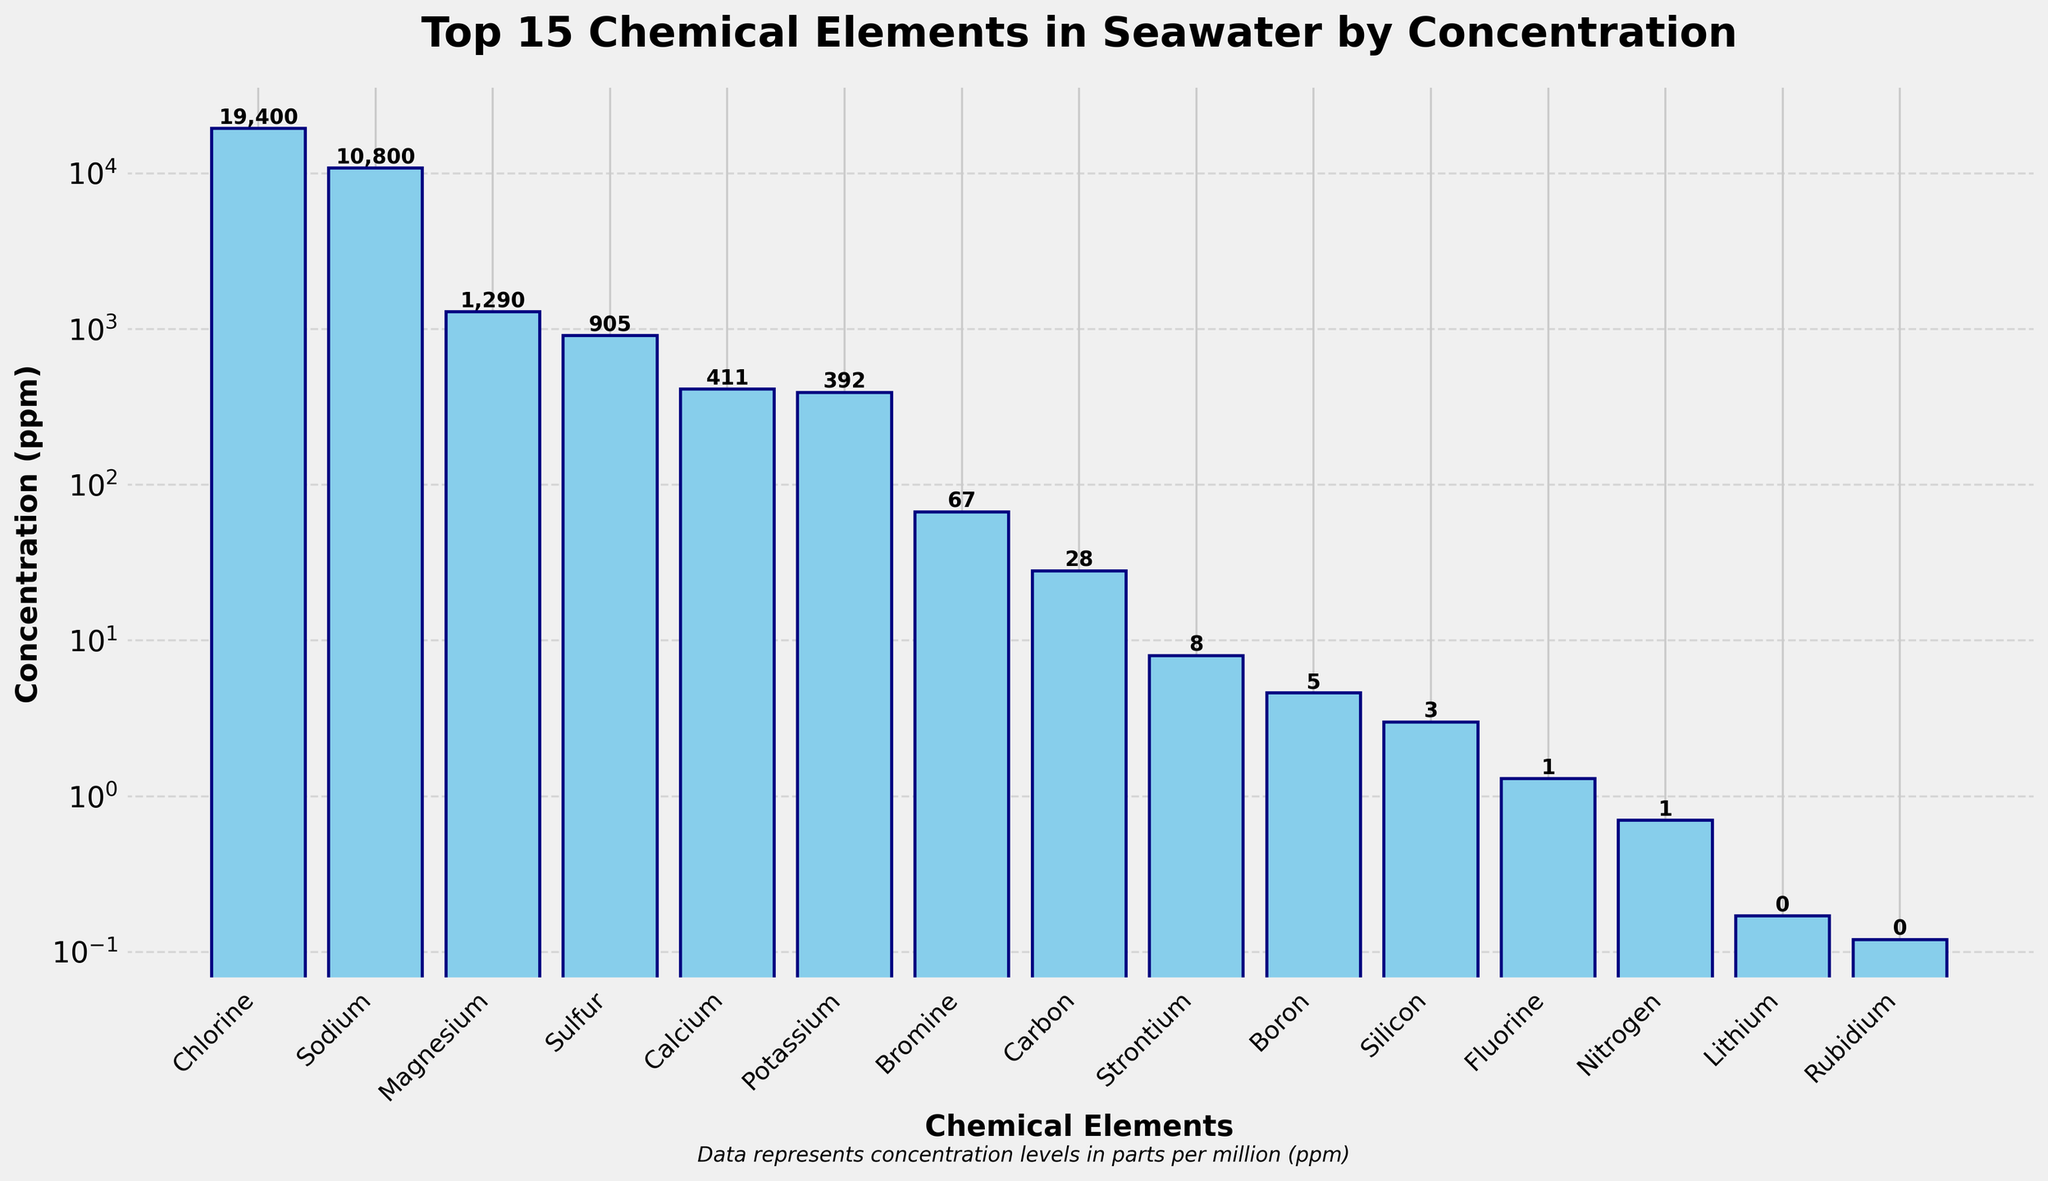Which element has the highest concentration in seawater? From the bar chart, observe the height of the bars. The tallest bar represents the element with the highest concentration.
Answer: Chlorine How does the concentration of sodium compare to that of chlorine? Compare the heights of the bars labeled 'Sodium' and 'Chlorine'. The bar for Chlorine is almost twice as high as the bar for Sodium, indicating Chlorine has a higher concentration.
Answer: Chlorine has a higher concentration than Sodium Is the concentration of magnesium higher than that of sulfur? Look at the bars for Magnesium and Sulfur. The bar for Magnesium is higher than the bar for Sulfur, indicating that the concentration of Magnesium is higher.
Answer: Yes What's the difference in concentration between calcium and potassium? Identify the bars for Calcium and Potassium and look at the numerical values on each. Calcium has a concentration of 411 ppm, and Potassium has 392 ppm. Subtract the smaller from the larger value.
Answer: 19 ppm Which elements have concentrations lower than 10 ppm? Examine the bars and their corresponding concentration values. Elements like Strontium, Boron, Silicon, and the remaining elements below Strontium have concentrations lower than 10 ppm.
Answer: Strontium, Boron, Silicon, Fluorine, Nitrogen, and others What's the combined concentration of chlorine, sodium, and magnesium? Sum the concentrations of Chlorine (19400 ppm), Sodium (10800 ppm), and Magnesium (1290 ppm). The combined concentration is 19400 + 10800 + 1290.
Answer: 31390 ppm Which element has the lowest concentration among the top 15 elements? Locate the shortest bar among the top 15 elements. This bar represents the element with the lowest concentration within the top 15 elements.
Answer: Fluorine Is there a large disparity between the concentrations of carbon and strontium? Compare the bars for Carbon and Strontium. Carbon's bar is significantly higher than Strontium's bar, indicating a noticeable disparity in concentrations.
Answer: Yes What is the average concentration of the top 3 most abundant elements? Find the concentrations of Chlorine (19400 ppm), Sodium (10800 ppm), and Magnesium (1290 ppm). Calculate their average: (19400 + 10800 + 1290) / 3.
Answer: 10563.33 ppm How many elements have concentrations above 1000 ppm? Count the number of bars with concentration values above 1000 ppm. These elements are Chlorine, Sodium, and Magnesium.
Answer: 3 